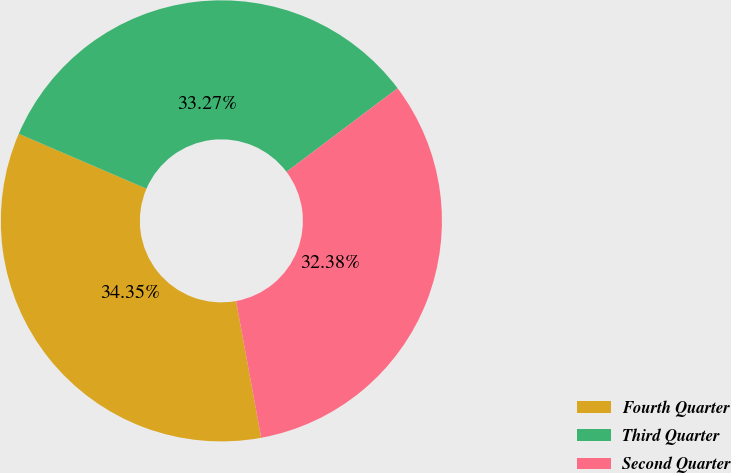<chart> <loc_0><loc_0><loc_500><loc_500><pie_chart><fcel>Fourth Quarter<fcel>Third Quarter<fcel>Second Quarter<nl><fcel>34.35%<fcel>33.27%<fcel>32.38%<nl></chart> 